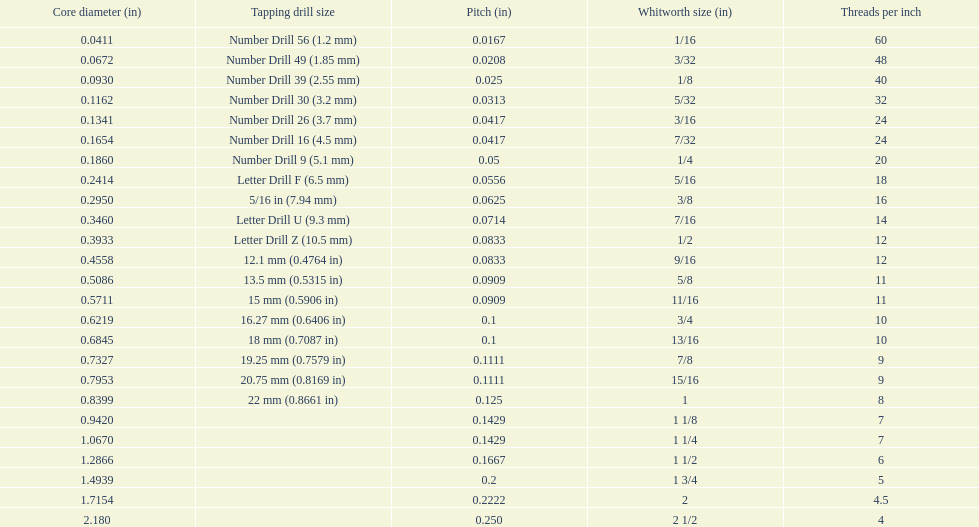How many more threads per inch does the 1/16th whitworth size have over the 1/8th whitworth size? 20. 